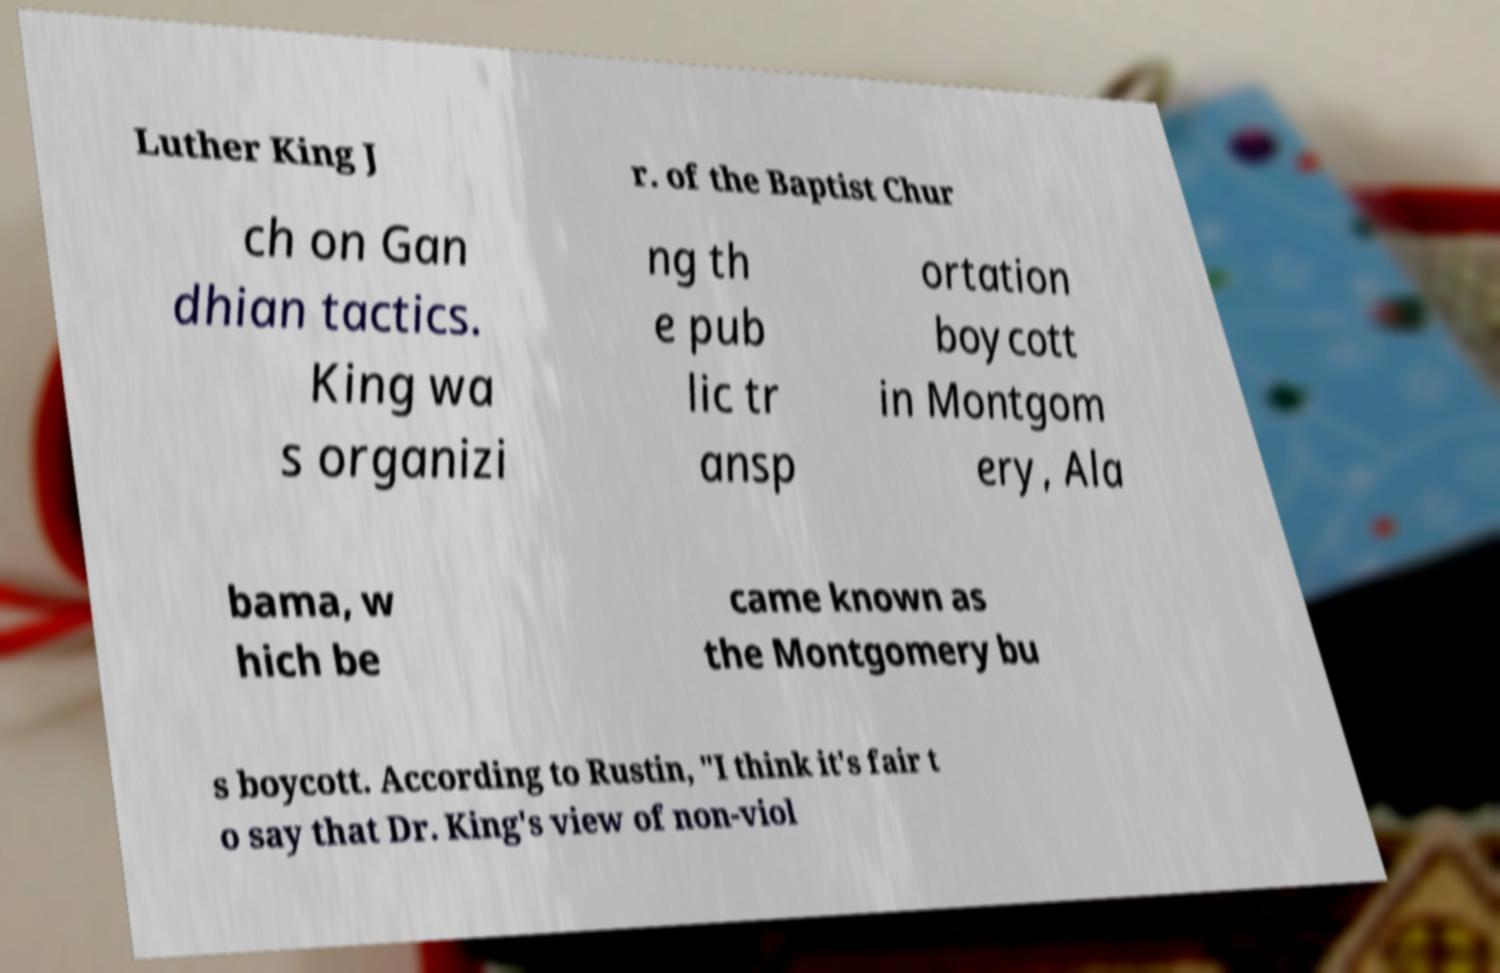Could you extract and type out the text from this image? Luther King J r. of the Baptist Chur ch on Gan dhian tactics. King wa s organizi ng th e pub lic tr ansp ortation boycott in Montgom ery, Ala bama, w hich be came known as the Montgomery bu s boycott. According to Rustin, "I think it's fair t o say that Dr. King's view of non-viol 